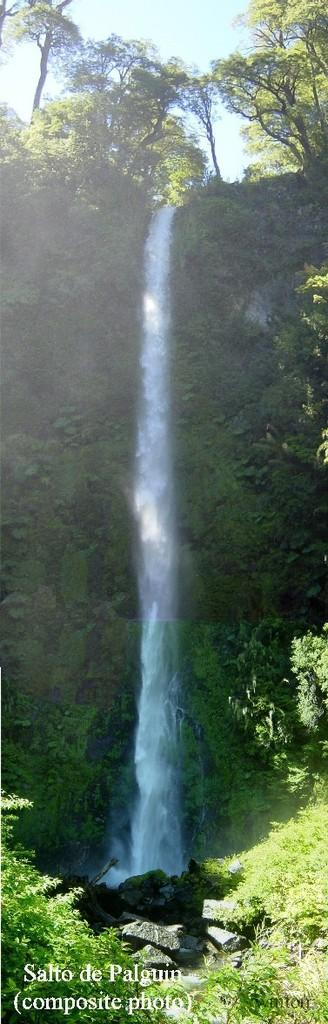What type of vegetation can be seen in the image? There are plants and trees in the image. What natural feature is located in the middle of the image? There is a waterfall in the middle of the image. Is there any text or marking visible in the image? Yes, there is a watermark in the left bottom of the image. How many brothers are standing near the waterfall in the image? There are no brothers present in the image; it features plants, trees, and a waterfall. What type of breath can be seen coming from the trees in the image? There is no breath visible in the image, as trees do not have the ability to breathe. 